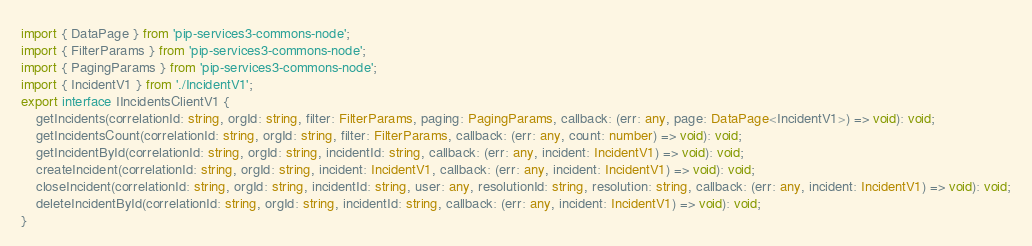<code> <loc_0><loc_0><loc_500><loc_500><_TypeScript_>import { DataPage } from 'pip-services3-commons-node';
import { FilterParams } from 'pip-services3-commons-node';
import { PagingParams } from 'pip-services3-commons-node';
import { IncidentV1 } from './IncidentV1';
export interface IIncidentsClientV1 {
    getIncidents(correlationId: string, orgId: string, filter: FilterParams, paging: PagingParams, callback: (err: any, page: DataPage<IncidentV1>) => void): void;
    getIncidentsCount(correlationId: string, orgId: string, filter: FilterParams, callback: (err: any, count: number) => void): void;
    getIncidentById(correlationId: string, orgId: string, incidentId: string, callback: (err: any, incident: IncidentV1) => void): void;
    createIncident(correlationId: string, orgId: string, incident: IncidentV1, callback: (err: any, incident: IncidentV1) => void): void;
    closeIncident(correlationId: string, orgId: string, incidentId: string, user: any, resolutionId: string, resolution: string, callback: (err: any, incident: IncidentV1) => void): void;
    deleteIncidentById(correlationId: string, orgId: string, incidentId: string, callback: (err: any, incident: IncidentV1) => void): void;
}
</code> 